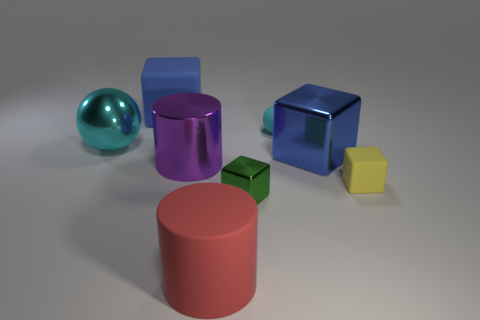Are the big object that is on the right side of the tiny cyan rubber object and the tiny yellow thing made of the same material? The large purple object on the right side of the small cyan object and the small yellow cube appear to have different surface textures and light reflections, suggesting that they are not made of the same material. The purple object has a glossy finish, indicating it might be made of plastic or a similar synthetic material, while the yellow cube has a matte finish that could imply it is made of another type of plastic or a different material altogether. 